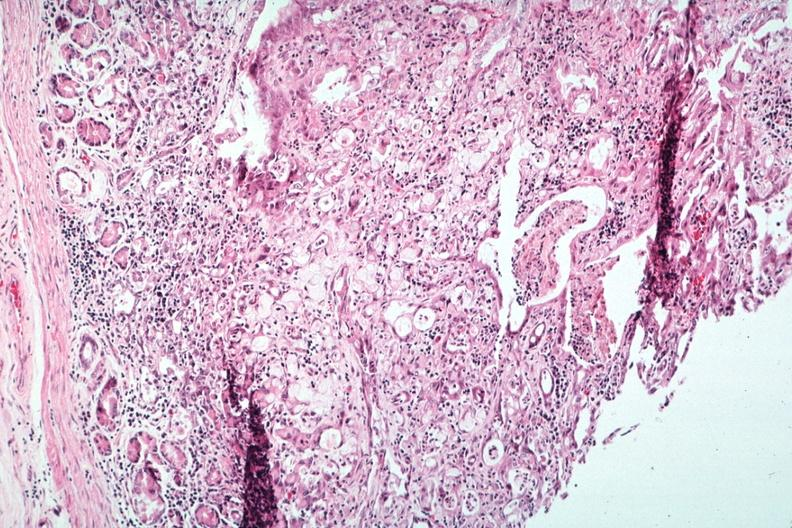what does this image show?
Answer the question using a single word or phrase. Stomach primary 